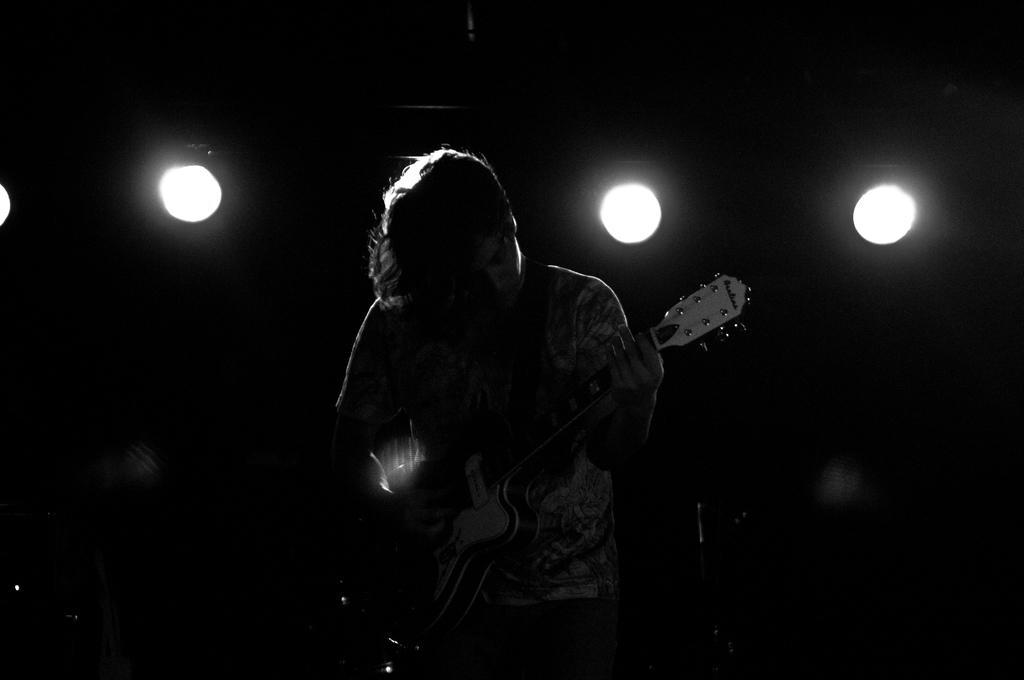What is the main subject of the image? There is a man in the image. What is the man doing in the image? The man is standing in the image. What object is the man holding in the image? The man is holding a guitar in his hand. What type of vessel is the man using to transport the guitar in the image? There is no vessel present in the image, and the man is not using any means to transport the guitar. 